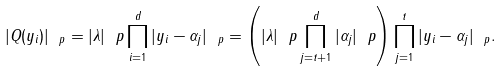Convert formula to latex. <formula><loc_0><loc_0><loc_500><loc_500>| { Q } ( y _ { i } ) | _ { \ p } = | \lambda | _ { \ } p \prod _ { i = 1 } ^ { d } | y _ { i } - \alpha _ { j } | _ { \ p } = \left ( | \lambda | _ { \ } p \prod _ { j = t + 1 } ^ { d } | \alpha _ { j } | _ { \ } p \right ) \prod _ { j = 1 } ^ { t } | { y _ { i } - \alpha _ { j } } | _ { \ p } .</formula> 